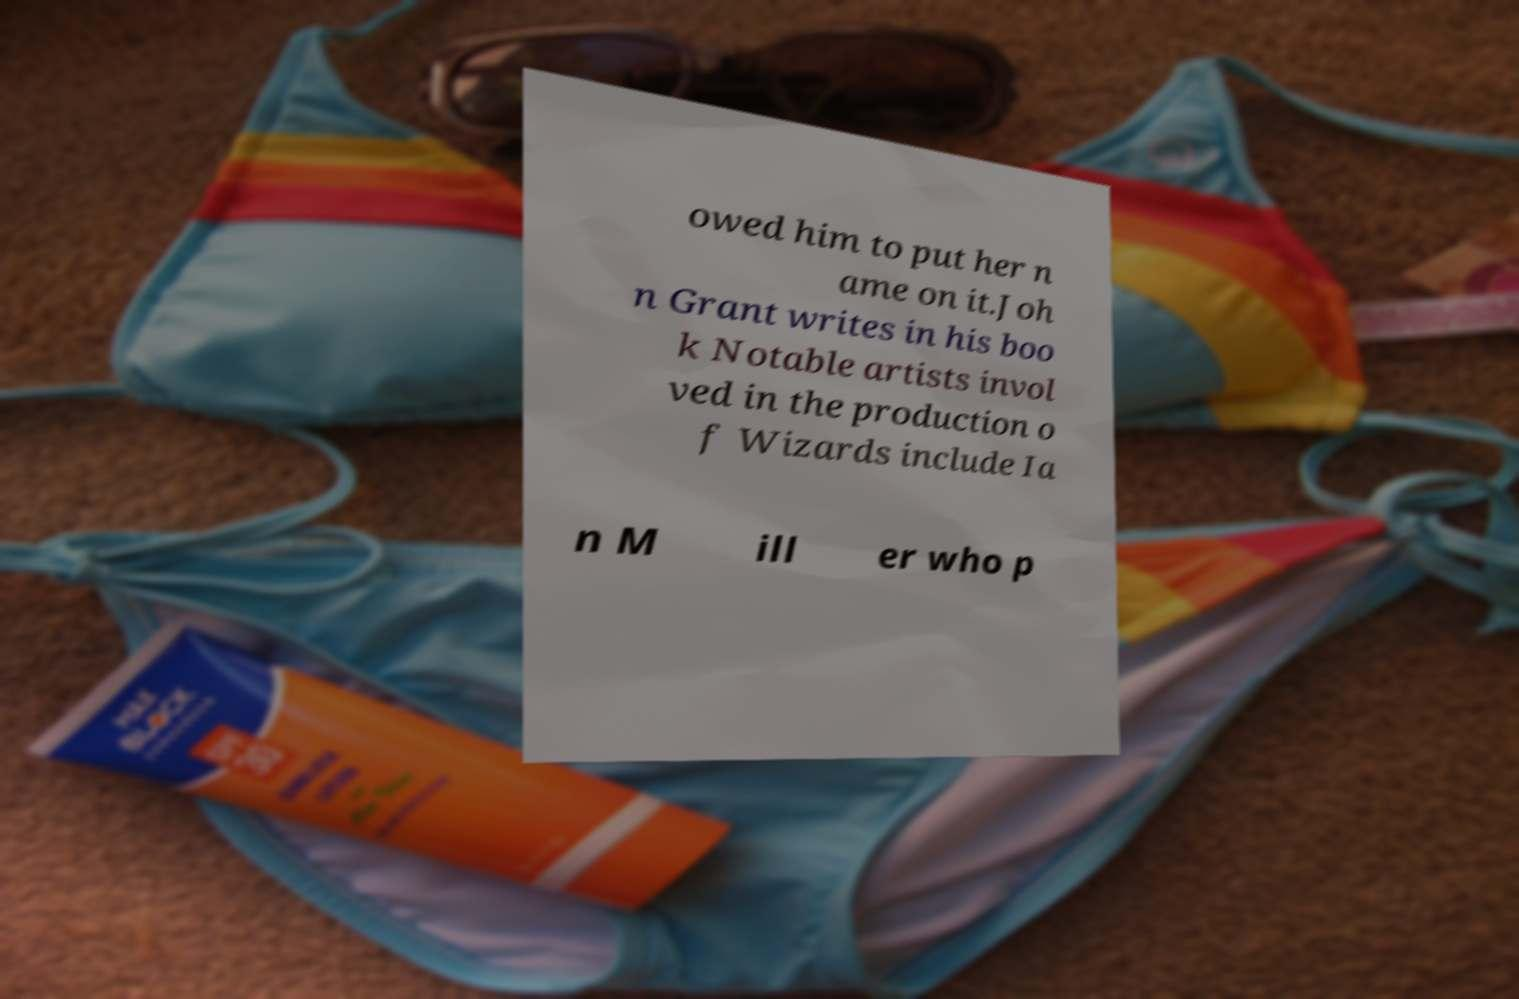There's text embedded in this image that I need extracted. Can you transcribe it verbatim? owed him to put her n ame on it.Joh n Grant writes in his boo k Notable artists invol ved in the production o f Wizards include Ia n M ill er who p 